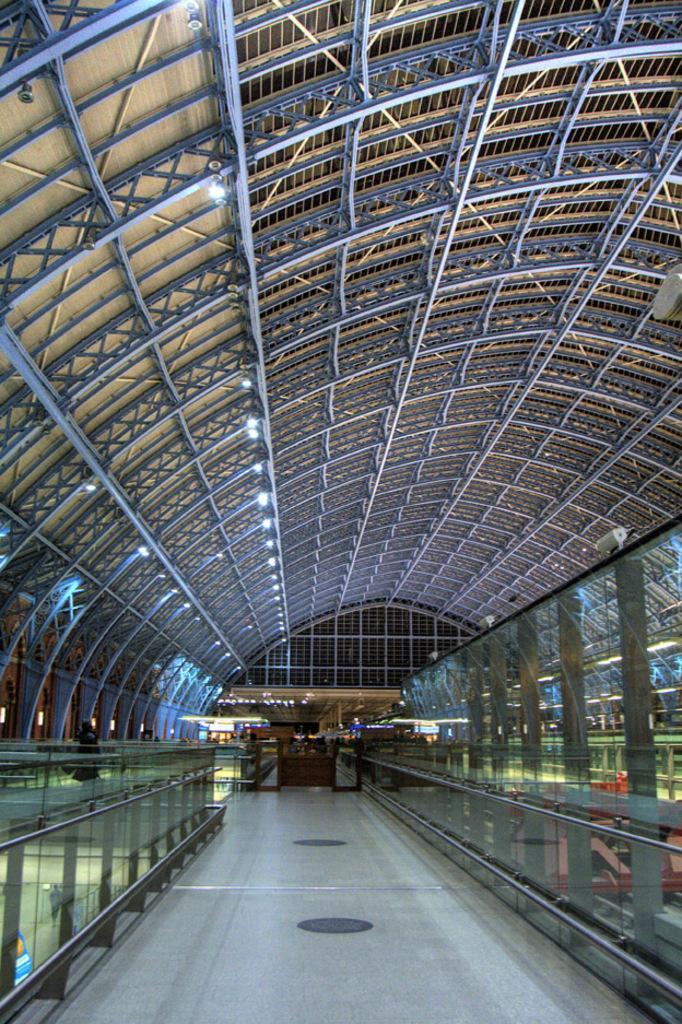Describe this image in one or two sentences. In this picture we can see on the path there is a glass fence and other items. There are ceiling lights on the top. 